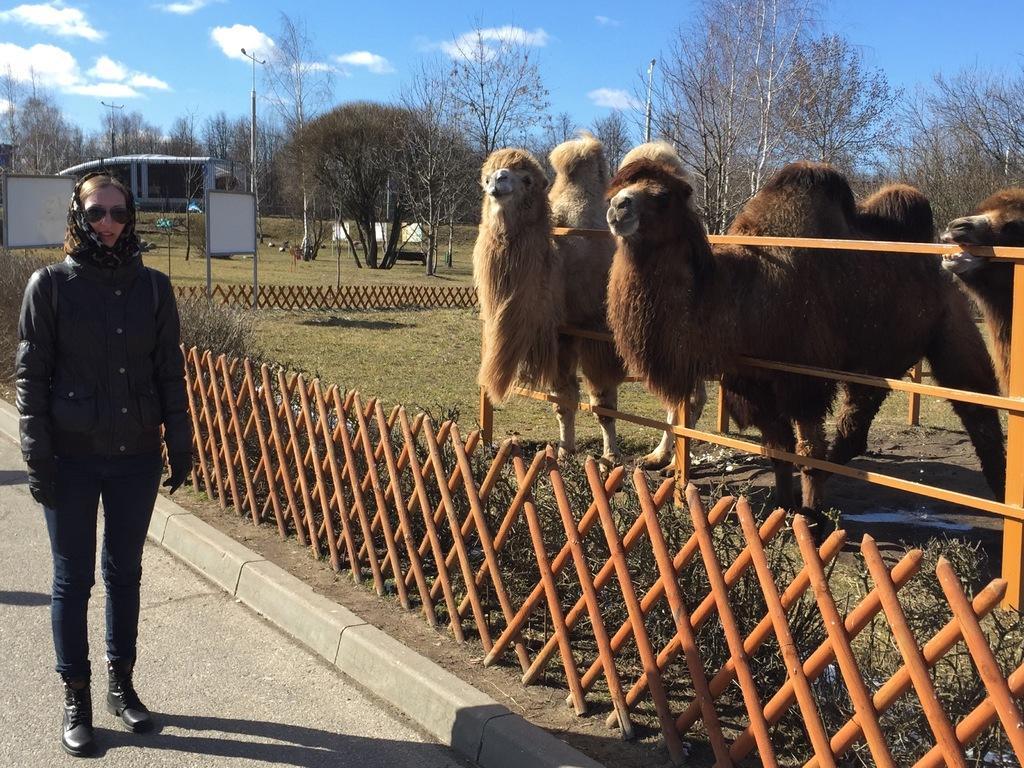Can you describe this image briefly? In this image I can see the ground, a person standing on the ground, the railing, few animals, few trees, few poles and few boards. In the background I can see the sky. 